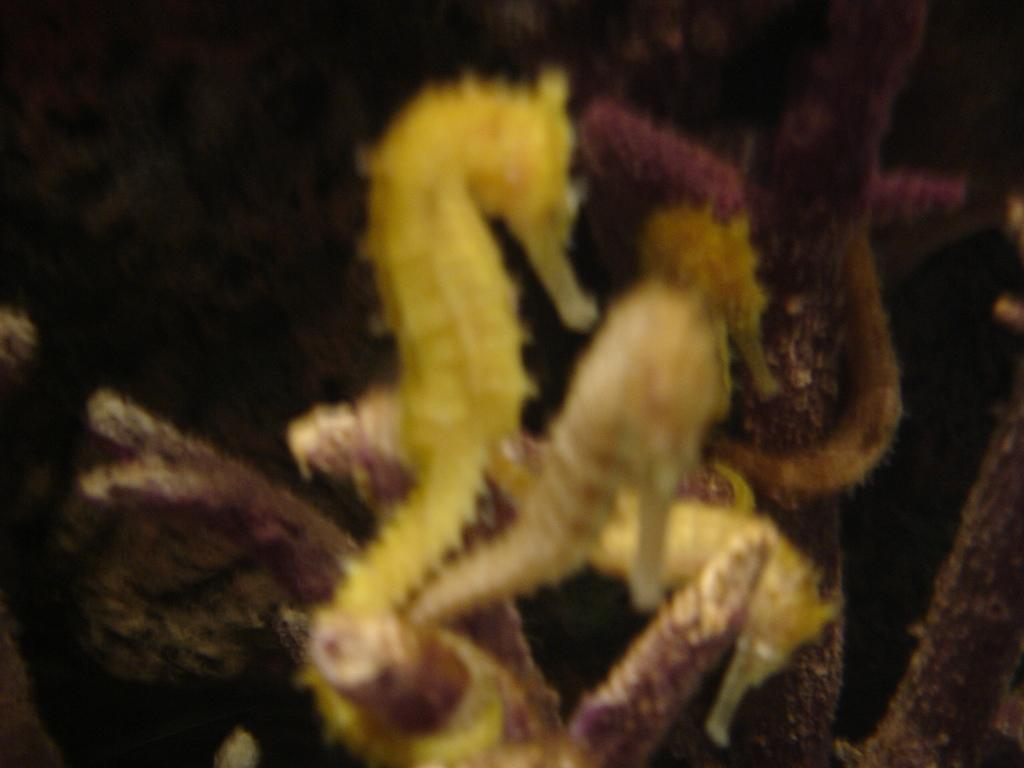What type of animals are in the image? There are seahorses in the image. Can you describe the background of the image? The background of the image is blurred. What type of train can be seen passing through the country in the image? There is no train or country present in the image; it features seahorses with a blurred background. What type of fruit is visible in the image? There is no fruit present in the image. 